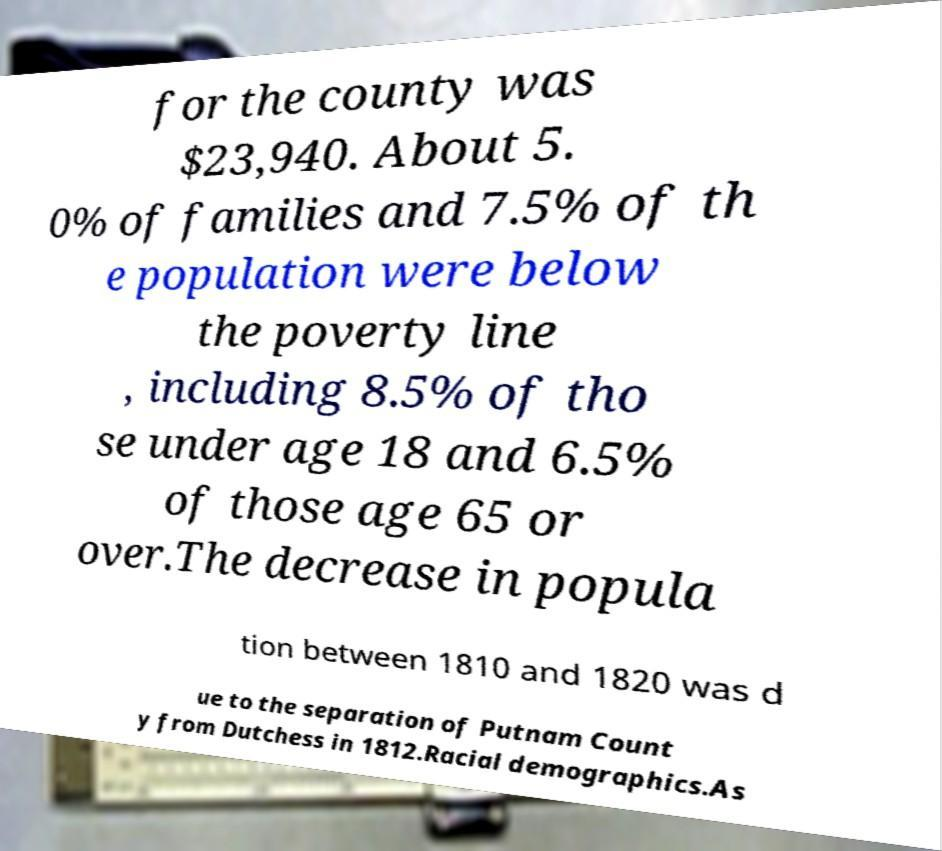Please read and relay the text visible in this image. What does it say? for the county was $23,940. About 5. 0% of families and 7.5% of th e population were below the poverty line , including 8.5% of tho se under age 18 and 6.5% of those age 65 or over.The decrease in popula tion between 1810 and 1820 was d ue to the separation of Putnam Count y from Dutchess in 1812.Racial demographics.As 